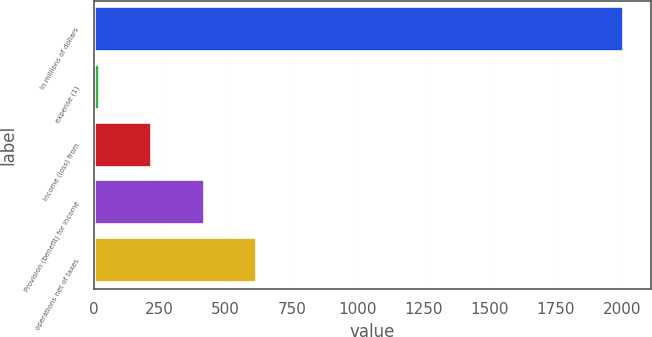Convert chart to OTSL. <chart><loc_0><loc_0><loc_500><loc_500><bar_chart><fcel>In millions of dollars<fcel>expense (1)<fcel>Income (loss) from<fcel>Provision (benefit) for income<fcel>operations net of taxes<nl><fcel>2008<fcel>24<fcel>222.4<fcel>420.8<fcel>619.2<nl></chart> 